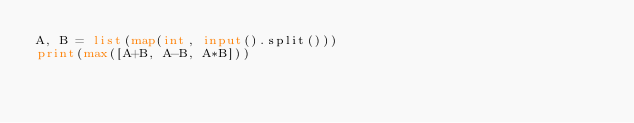<code> <loc_0><loc_0><loc_500><loc_500><_Python_>A, B = list(map(int, input().split()))
print(max([A+B, A-B, A*B]))
</code> 